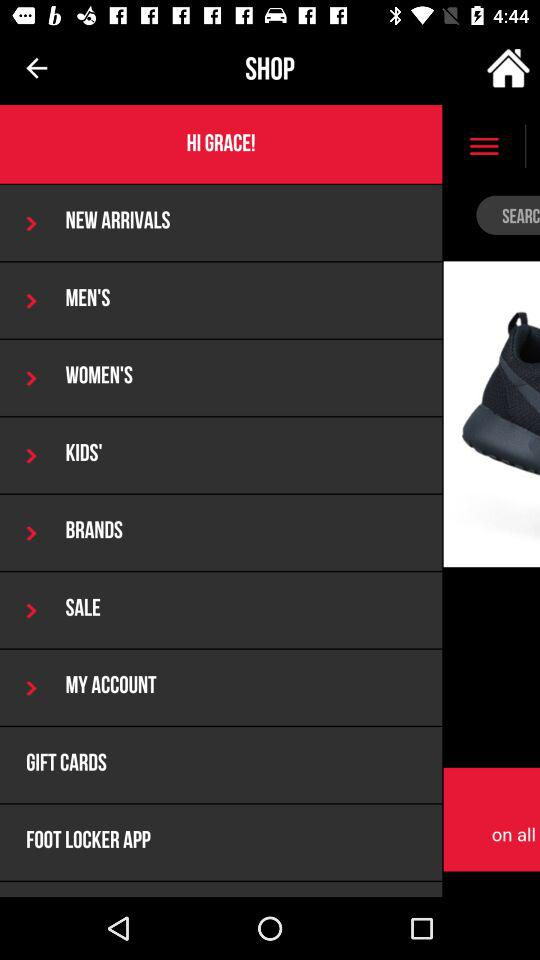How many months are available to select in the calendar?
Answer the question using a single word or phrase. 12 